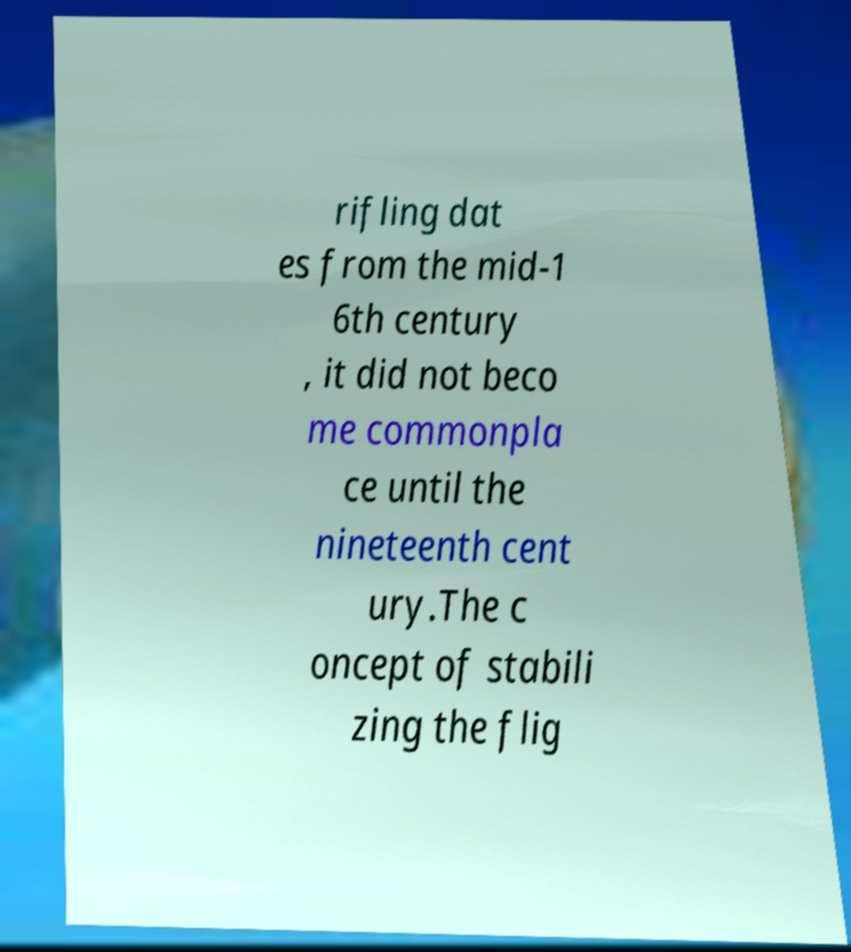There's text embedded in this image that I need extracted. Can you transcribe it verbatim? rifling dat es from the mid-1 6th century , it did not beco me commonpla ce until the nineteenth cent ury.The c oncept of stabili zing the flig 